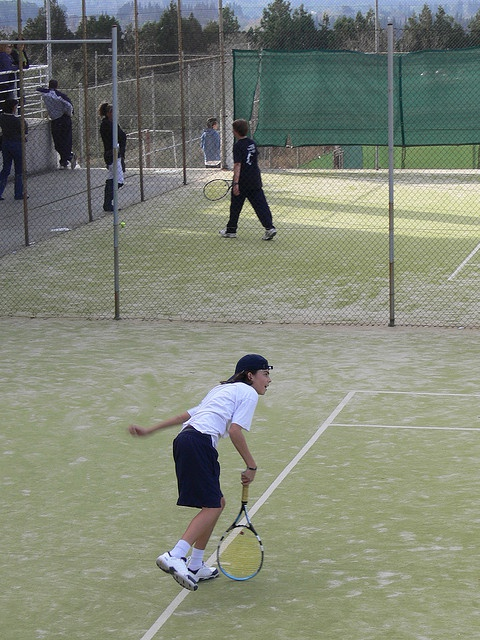Describe the objects in this image and their specific colors. I can see people in darkgray, black, and gray tones, people in darkgray, black, and gray tones, tennis racket in darkgray, olive, gray, and black tones, people in darkgray, black, gray, and navy tones, and people in darkgray, black, and gray tones in this image. 